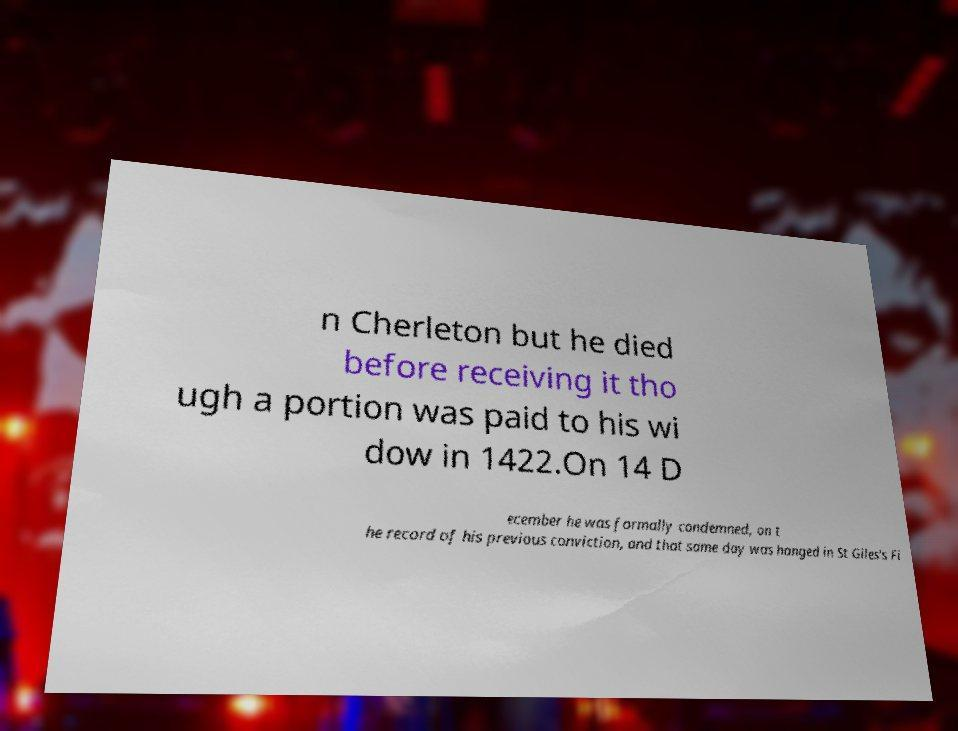There's text embedded in this image that I need extracted. Can you transcribe it verbatim? n Cherleton but he died before receiving it tho ugh a portion was paid to his wi dow in 1422.On 14 D ecember he was formally condemned, on t he record of his previous conviction, and that same day was hanged in St Giles's Fi 